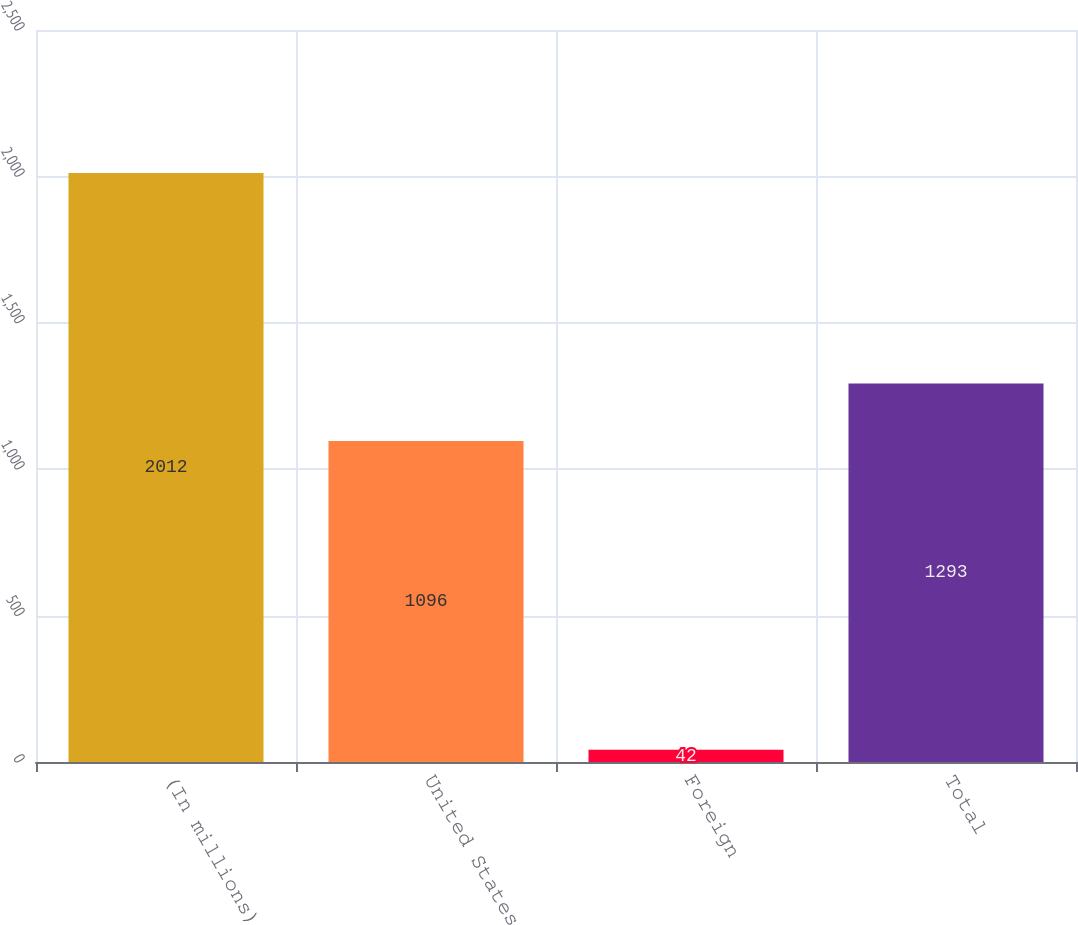Convert chart. <chart><loc_0><loc_0><loc_500><loc_500><bar_chart><fcel>(In millions)<fcel>United States<fcel>Foreign<fcel>Total<nl><fcel>2012<fcel>1096<fcel>42<fcel>1293<nl></chart> 